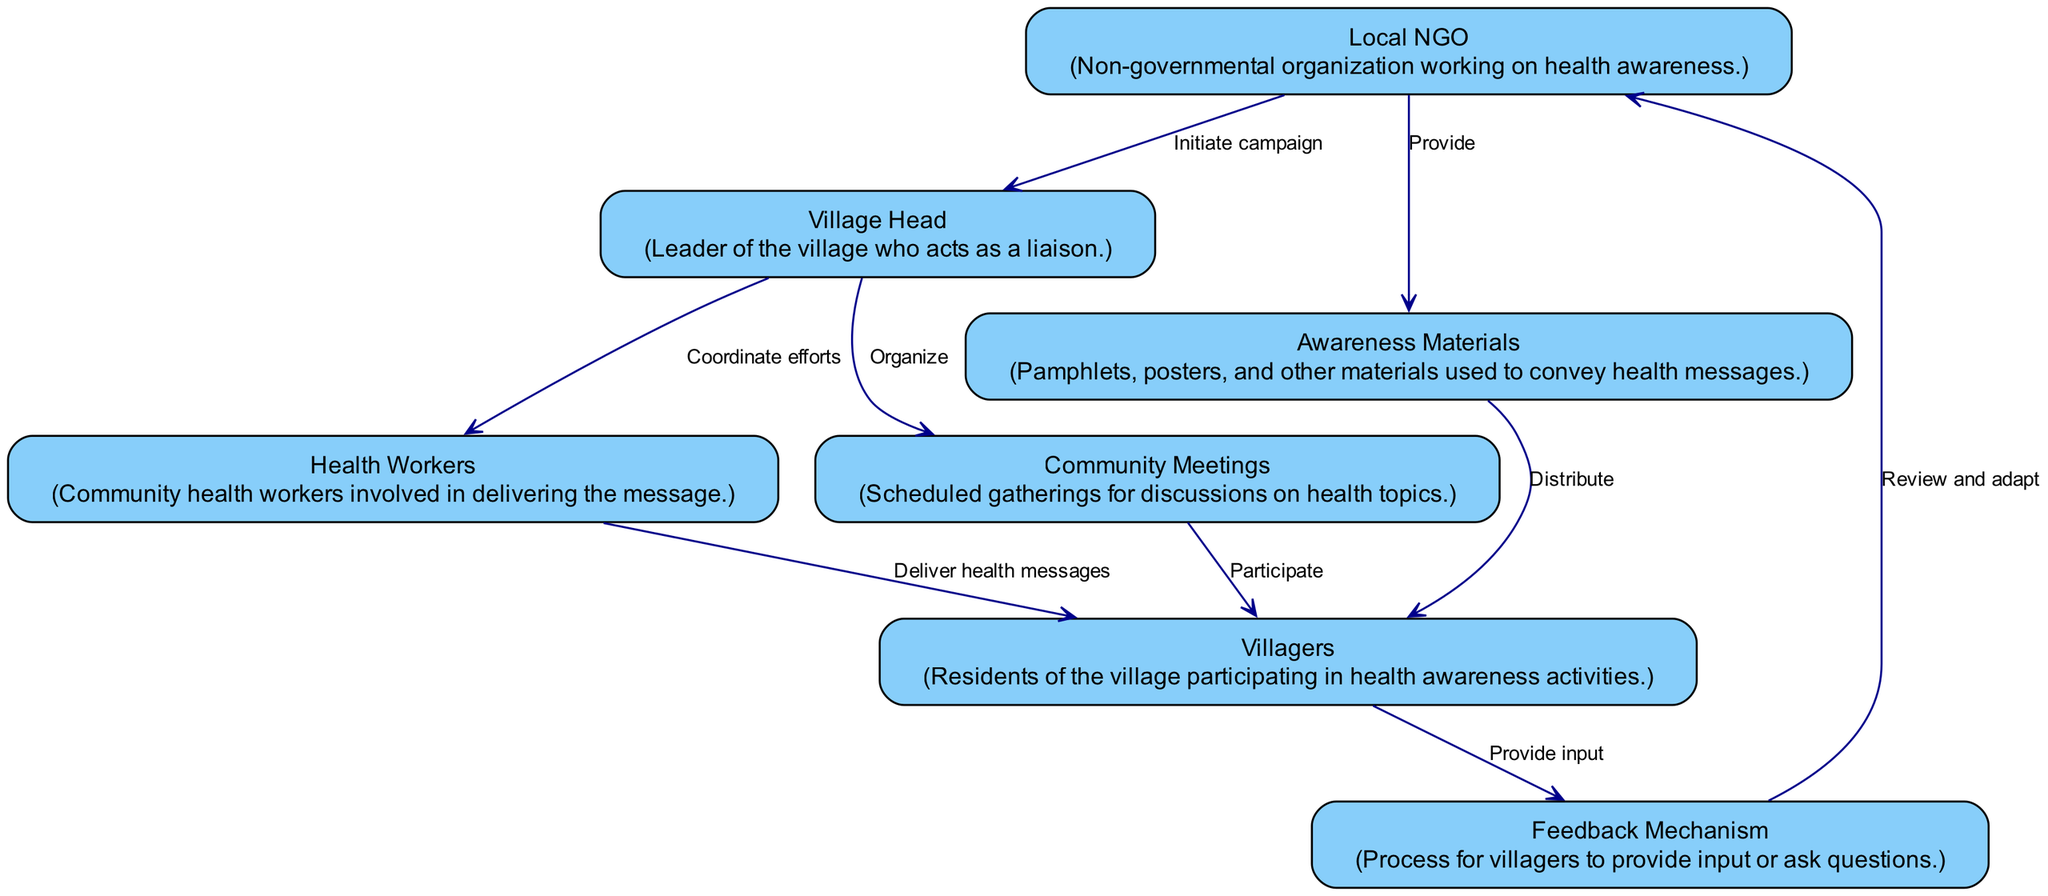What is the first action taken in the communication flow? The first action in the flow is initiated by the "Local NGO," who begins the health awareness campaign. This is depicted by the arrow coming from the "Local NGO" to the "Village Head."
Answer: Initiate campaign How many nodes are represented in the diagram? The diagram includes a total of seven nodes representing distinct elements of the communication flow, which are "Local NGO," "Village Head," "Health Workers," "Villagers," "Awareness Materials," "Community Meetings," and "Feedback Mechanism."
Answer: Seven What role does the Village Head play in the communication process? The "Village Head" acts as a liaison and is responsible for coordinating efforts among the "Health Workers" and organizing "Community Meetings." This is indicated by the edges directed from the "Village Head" to those nodes.
Answer: Coordinator Which node receives the "Feedback Mechanism"? The "Local NGO" receives feedback as indicated by the edge that flows from the "Feedback Mechanism" back to the "Local NGO." This feedback helps the NGO to review and adapt the campaign based on villagers' inputs.
Answer: Local NGO What materials are provided by the Local NGO? The "Local NGO" provides "Awareness Materials," which include pamphlets and posters to help convey health messages to the villagers, as shown in the arrow from "Local NGO" to "Awareness Materials."
Answer: Awareness Materials How do villagers participate in health discussions? Villagers participate in health discussions through "Community Meetings," which are organized by the "Village Head." This is shown by the directed edge from "Community Meetings" to "Villagers."
Answer: Community Meetings What happens after villagers provide input through the Feedback Mechanism? After the villagers provide input through the "Feedback Mechanism," the "Local NGO" reviews and adapts their strategies based on the feedback returned from this process. This is indicated by the edge flowing from "Feedback Mechanism" to "Local NGO."
Answer: Review and adapt In the sequence, who is responsible for delivering health messages? The responsibility for delivering health messages is held by the "Health Workers," who receive coordination from the "Village Head" and pass the messages on to the "Villagers." This is shown by the connection from "Health Workers" to "Villagers."
Answer: Health Workers 